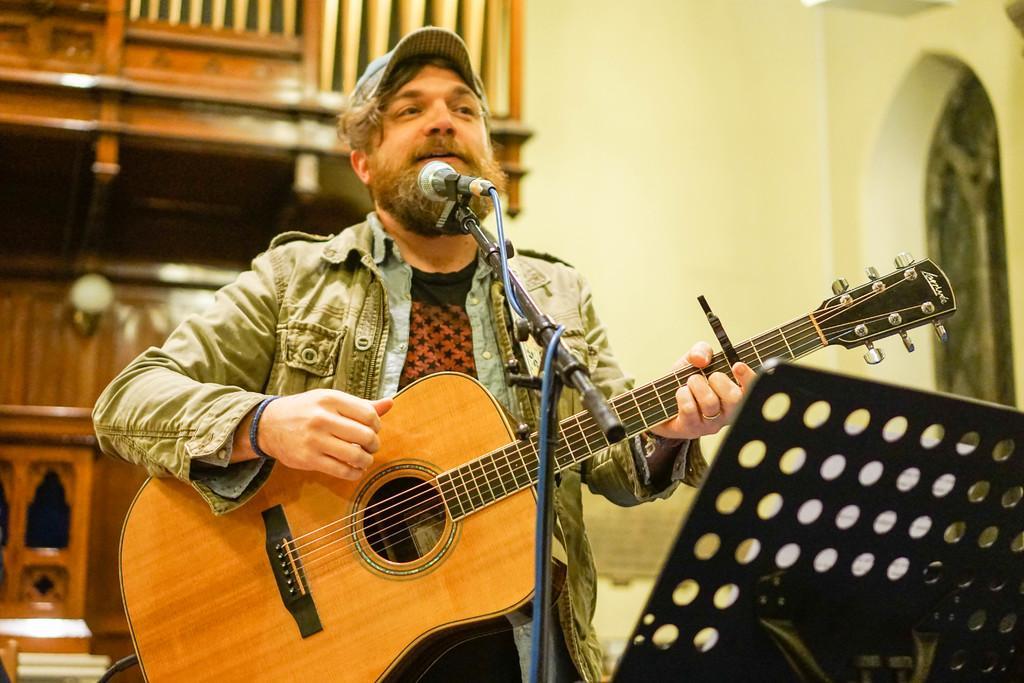Describe this image in one or two sentences. In this image there is a man standing. He is singing and playing guitar as well. In front of him there is a microphone and its stand. To the below right corner there is a book holder. In the background there is wall. 